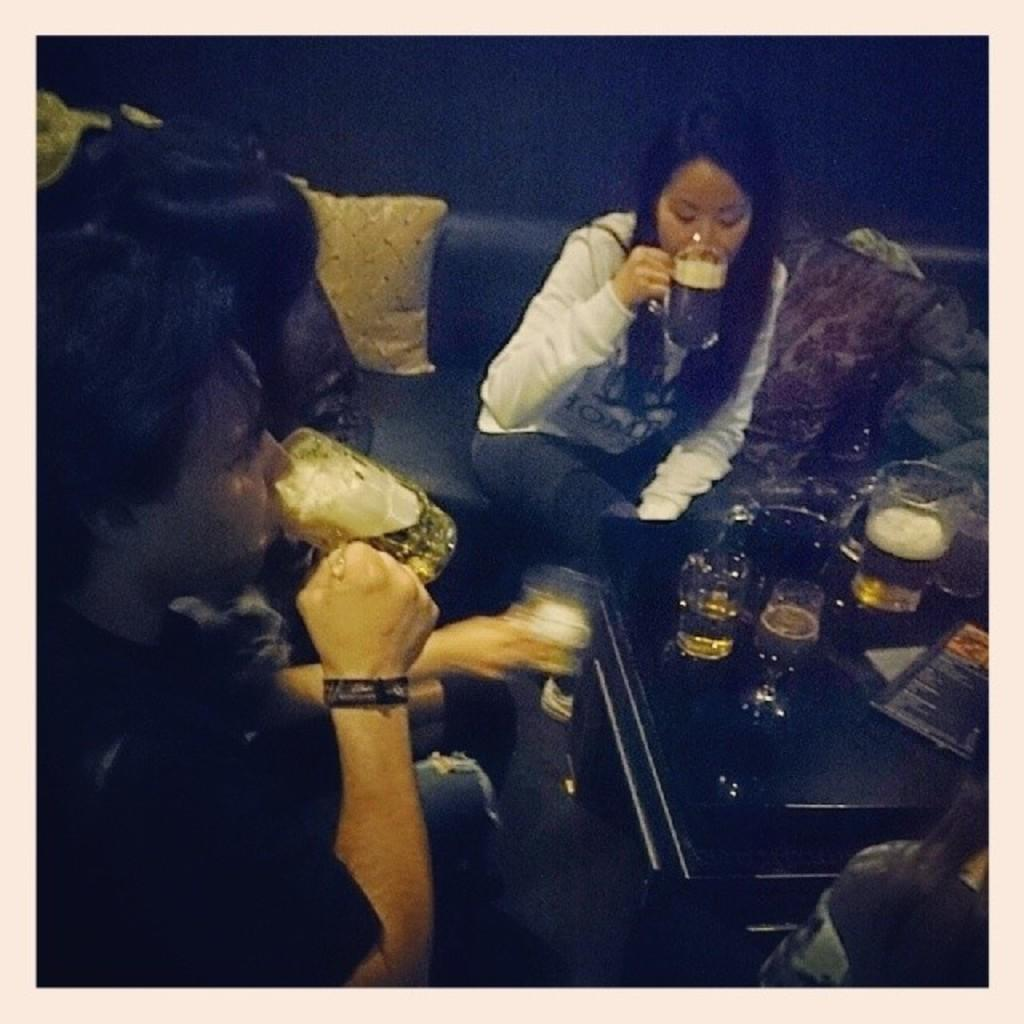What are the people in the image doing? The people in the image are sitting on a sofa. What are the people holding or consuming? The people are having drinks. What type of containers can be seen in the image? There are glass bottles and glasses in the image. What is present on the table in the image? There are objects on the table. Can you see any roses on the table in the image? There is no mention of roses in the image, so we cannot determine if any are present. What type of crackers are being served with the drinks in the image? There is no mention of crackers in the image, so we cannot determine if any are being served. 